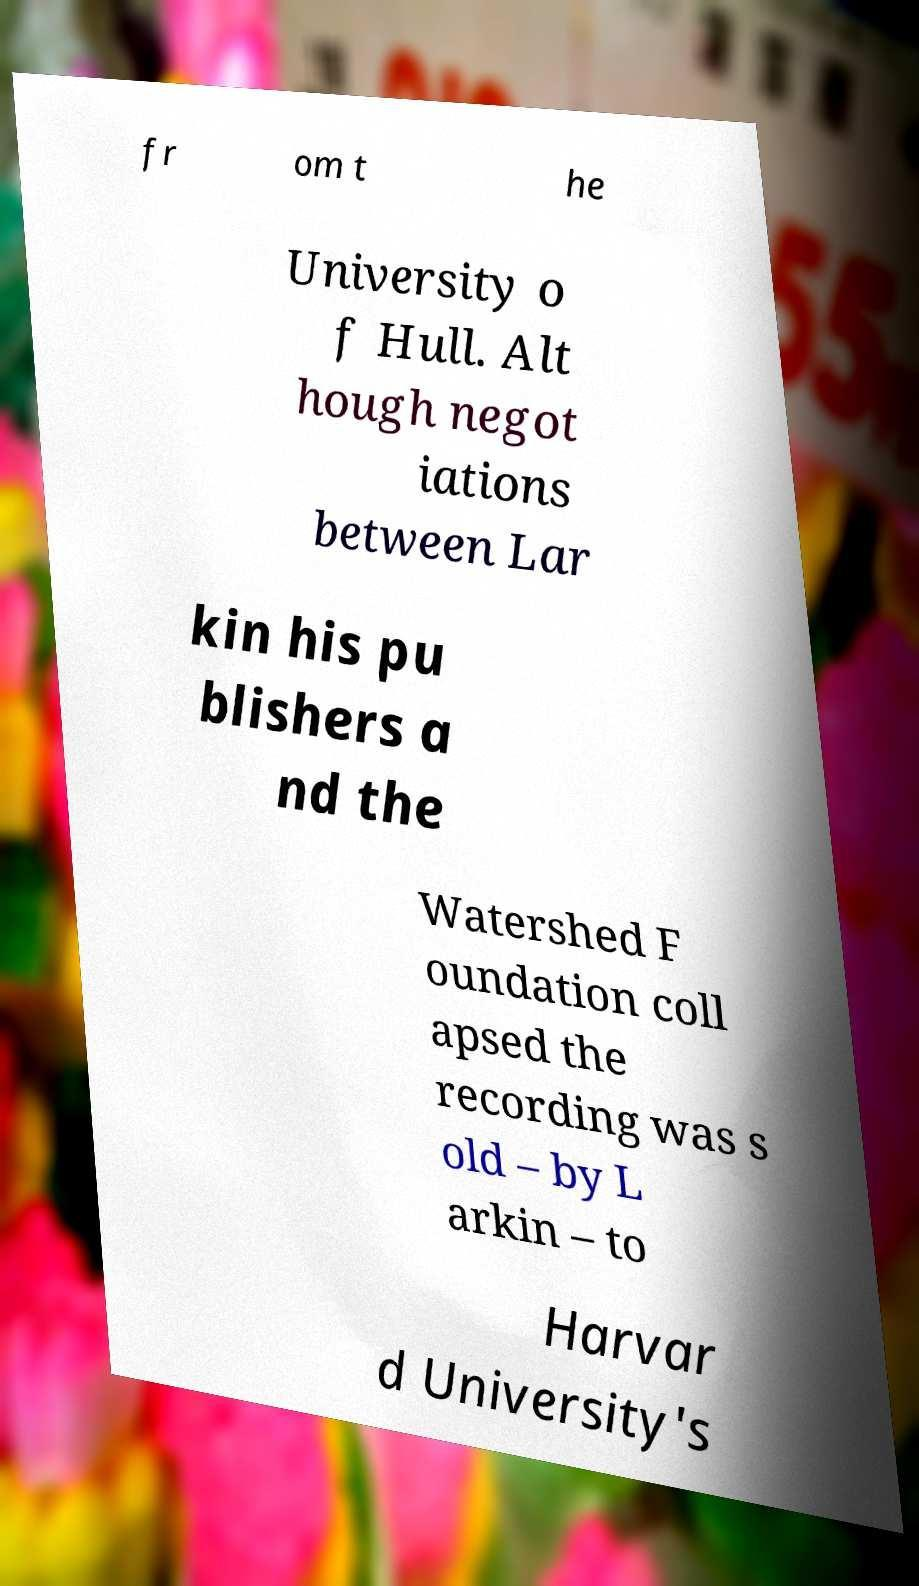I need the written content from this picture converted into text. Can you do that? fr om t he University o f Hull. Alt hough negot iations between Lar kin his pu blishers a nd the Watershed F oundation coll apsed the recording was s old – by L arkin – to Harvar d University's 